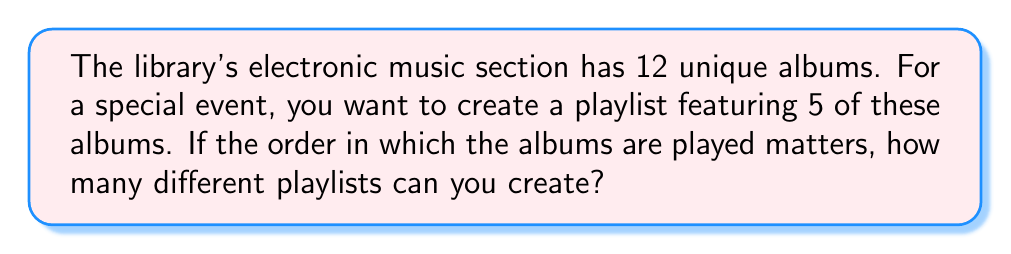Give your solution to this math problem. To solve this problem, we need to use the concept of permutations. Permutations are used when the order of selection matters, which is the case for a playlist where the sequence of albums is important.

The formula for permutations is:

$$P(n,r) = \frac{n!}{(n-r)!}$$

Where:
$n$ = total number of items to choose from
$r$ = number of items being chosen

In this case:
$n = 12$ (total number of albums)
$r = 5$ (number of albums in the playlist)

Let's substitute these values into the formula:

$$P(12,5) = \frac{12!}{(12-5)!} = \frac{12!}{7!}$$

Now, let's calculate this step-by-step:

1) $12! = 12 \times 11 \times 10 \times 9 \times 8 \times 7!$

2) Simplify:
   $$\frac{12!}{7!} = \frac{12 \times 11 \times 10 \times 9 \times 8 \times 7!}{7!}$$

3) The $7!$ cancels out in the numerator and denominator:
   $$12 \times 11 \times 10 \times 9 \times 8 = 95,040$$

Therefore, there are 95,040 different possible playlists that can be created.
Answer: 95,040 possible playlists 